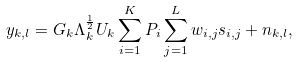Convert formula to latex. <formula><loc_0><loc_0><loc_500><loc_500>y _ { k , l } = G _ { k } \Lambda _ { k } ^ { \frac { 1 } { 2 } } U _ { k } \sum ^ { K } _ { i = 1 } P _ { i } \sum ^ { L } _ { j = 1 } w _ { i , j } s _ { i , j } + n _ { k , l } ,</formula> 